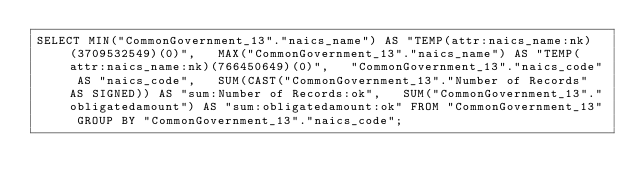Convert code to text. <code><loc_0><loc_0><loc_500><loc_500><_SQL_>SELECT MIN("CommonGovernment_13"."naics_name") AS "TEMP(attr:naics_name:nk)(3709532549)(0)",   MAX("CommonGovernment_13"."naics_name") AS "TEMP(attr:naics_name:nk)(766450649)(0)",   "CommonGovernment_13"."naics_code" AS "naics_code",   SUM(CAST("CommonGovernment_13"."Number of Records" AS SIGNED)) AS "sum:Number of Records:ok",   SUM("CommonGovernment_13"."obligatedamount") AS "sum:obligatedamount:ok" FROM "CommonGovernment_13" GROUP BY "CommonGovernment_13"."naics_code";
</code> 